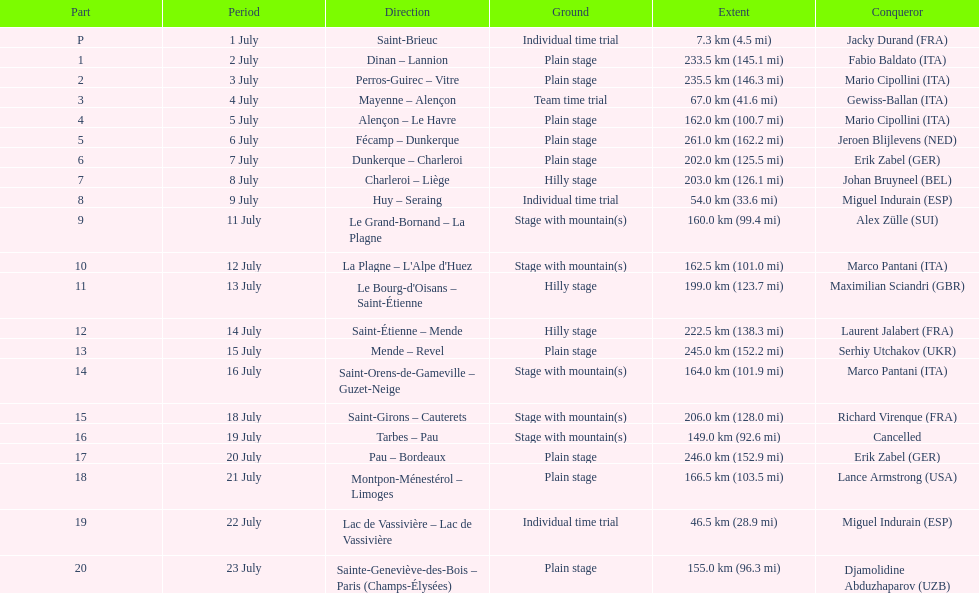Which itineraries were at least 100 kilometers? Dinan - Lannion, Perros-Guirec - Vitre, Alençon - Le Havre, Fécamp - Dunkerque, Dunkerque - Charleroi, Charleroi - Liège, Le Grand-Bornand - La Plagne, La Plagne - L'Alpe d'Huez, Le Bourg-d'Oisans - Saint-Étienne, Saint-Étienne - Mende, Mende - Revel, Saint-Orens-de-Gameville - Guzet-Neige, Saint-Girons - Cauterets, Tarbes - Pau, Pau - Bordeaux, Montpon-Ménestérol - Limoges, Sainte-Geneviève-des-Bois - Paris (Champs-Élysées). 